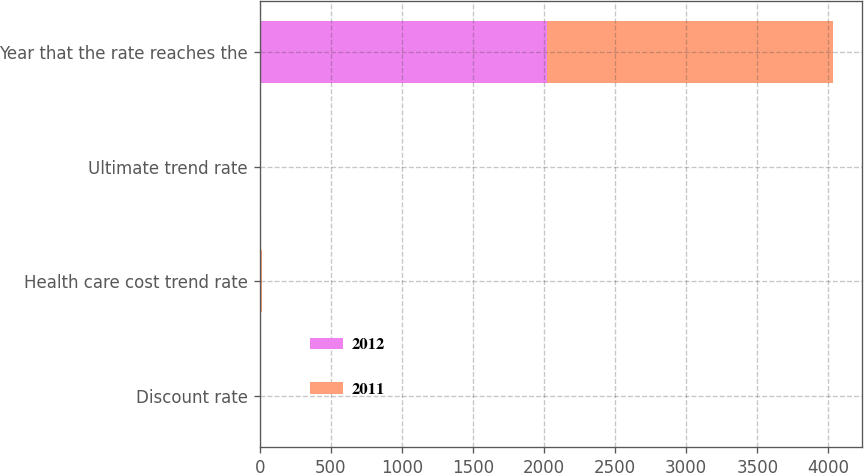Convert chart. <chart><loc_0><loc_0><loc_500><loc_500><stacked_bar_chart><ecel><fcel>Discount rate<fcel>Health care cost trend rate<fcel>Ultimate trend rate<fcel>Year that the rate reaches the<nl><fcel>2012<fcel>3.9<fcel>7.5<fcel>5<fcel>2018<nl><fcel>2011<fcel>4.9<fcel>8<fcel>5<fcel>2018<nl></chart> 